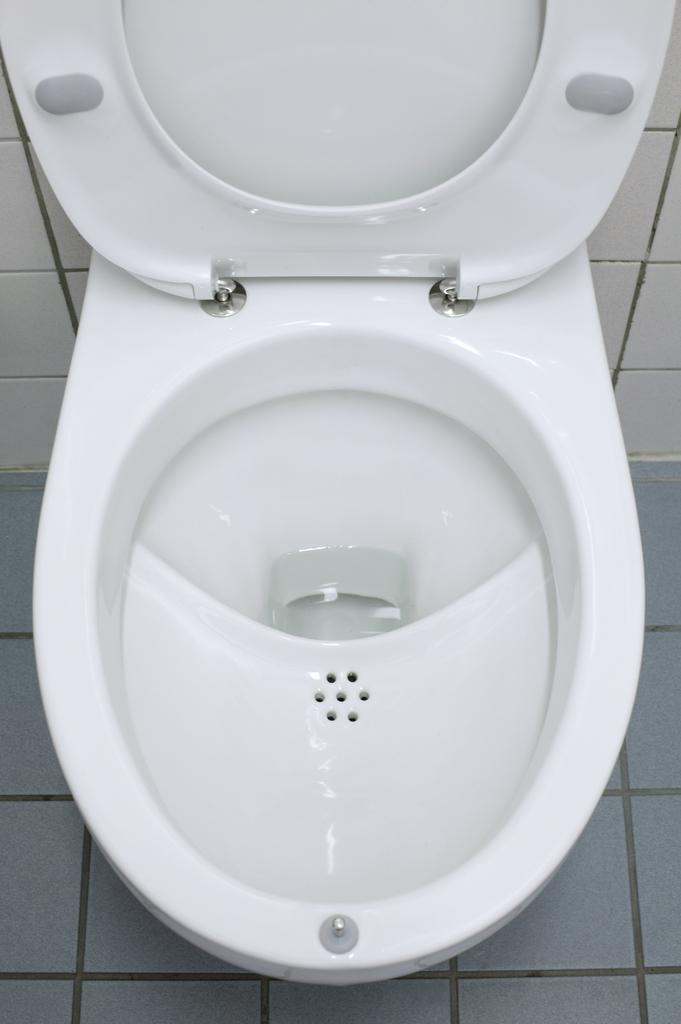What is the main object in the image? There is a toilet seat in the image. What type of flooring is present in the image? The toilet seat is surrounded by tiles. In which room is the image set? The image is set in a washroom. How many pets are visible in the image? There are no pets present in the image. What type of arch can be seen in the image? There is no arch present in the image. 